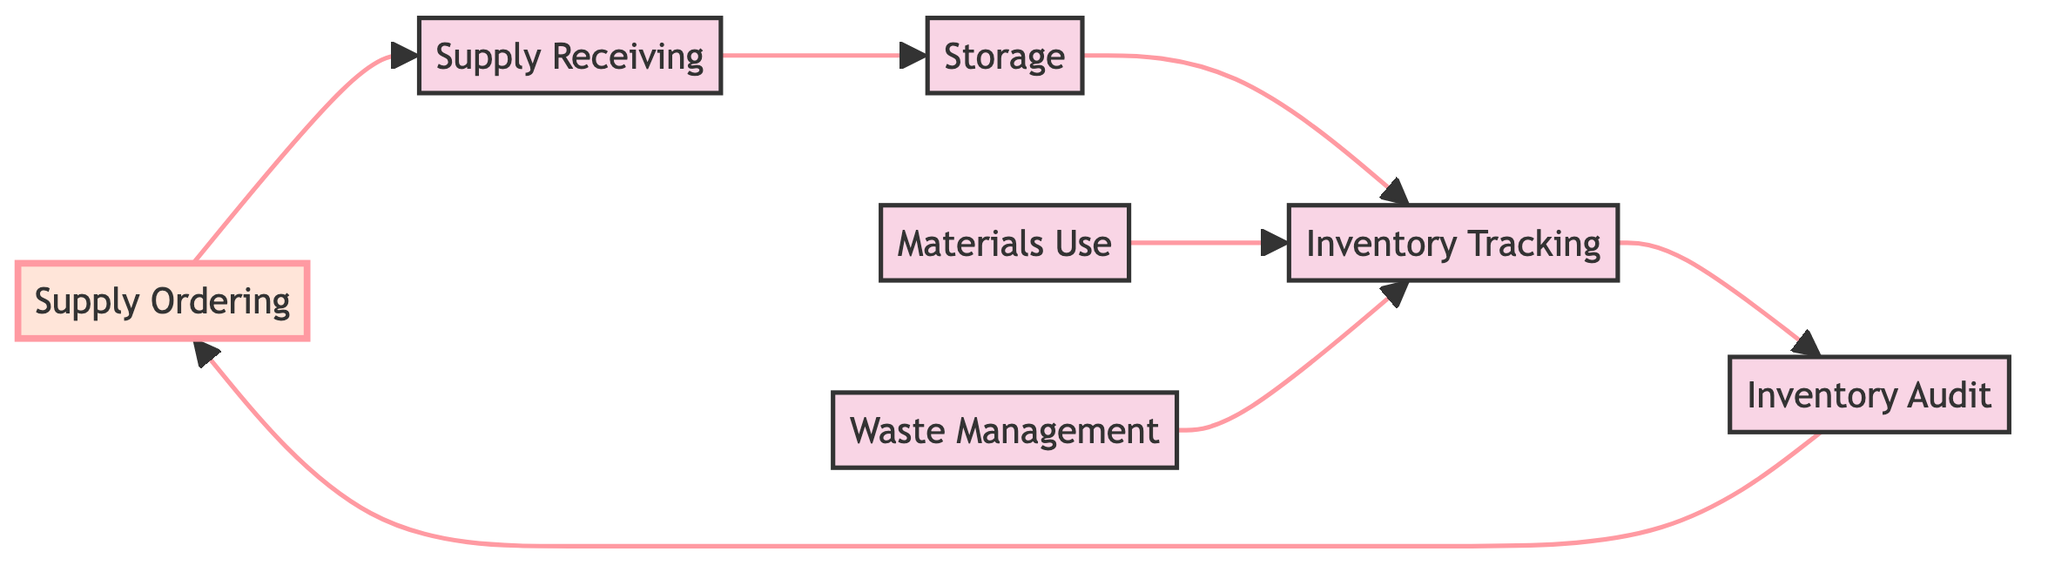What is the starting process in the inventory management flow? The starting process is depicted as "Supply Ordering," which is the first node in the diagram.
Answer: Supply Ordering How many nodes are present in the diagram? By counting each distinct block in the flowchart, we can see that there are a total of seven nodes.
Answer: Seven What does the "Supply Receiving" process connect to? The "Supply Receiving" process connects directly to the "Storage" process, as indicated by the arrow in the diagram.
Answer: Storage Which process is connected to both "Materials Use" and "Waste Management"? Both "Materials Use" and "Waste Management" connect to "Inventory Tracking," indicating how they influence the monitoring of supplies.
Answer: Inventory Tracking What is the final process that connects back to "Supply Ordering"? The "Inventory Audit" process connects back to "Supply Ordering," completing the cycle of inventory management as shown by the arrows.
Answer: Inventory Audit How many connections are flowing out of "Inventory Tracking"? There are three connections flowing out of "Inventory Tracking," leading to "Inventory Audit," "Materials Use," and "Waste Management."
Answer: Three If the inventory is audited, what happens next? After the inventory is audited, the process flows back to "Supply Ordering," suggesting that the outcome of the audit influences future ordering decisions.
Answer: Supply Ordering What type of inventory management element focuses on the loss of supplies? The "Waste Management" element specifically addresses the handling and documentation of any wastage of baking supplies in the diagram.
Answer: Waste Management Which process follows "Supply Receiving" directly in the sequence? The process that follows "Supply Receiving" directly in the sequence is "Storage," indicating that received supplies are stored right after being logged.
Answer: Storage In what order do the processes proceed from "Supply Ordering" to "Inventory Audit"? The order of processes is "Supply Ordering," then to "Supply Receiving," followed by "Storage," and finally to "Inventory Tracking" before reaching "Inventory Audit."
Answer: Supply Ordering, Supply Receiving, Storage, Inventory Tracking, Inventory Audit 